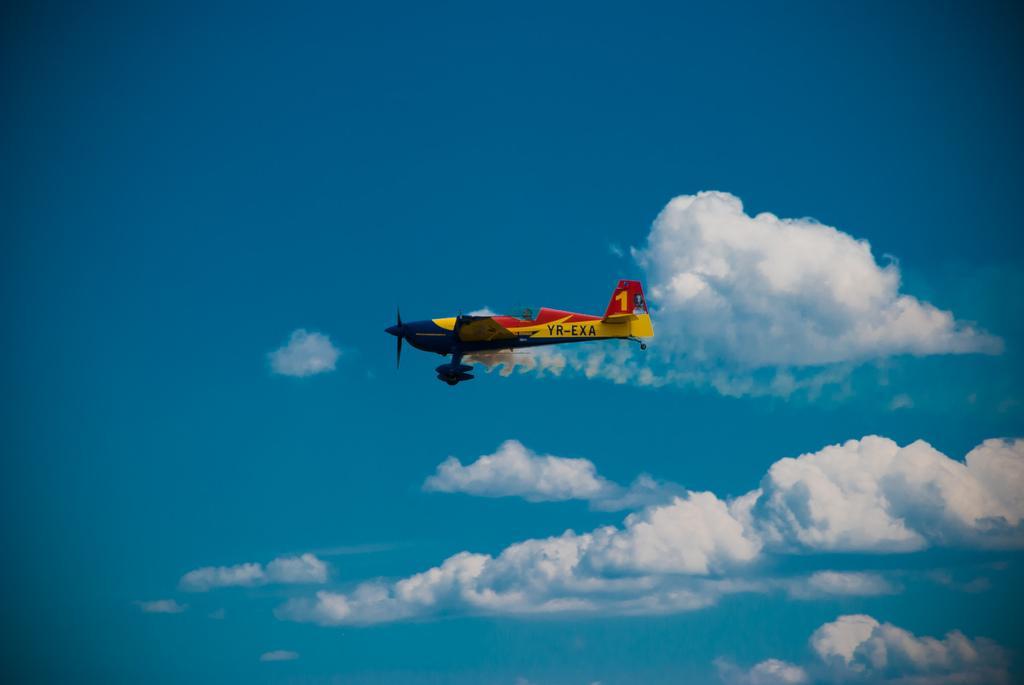Please provide a concise description of this image. In this image we can see a glider in sky. In background of the image there are clouds. 